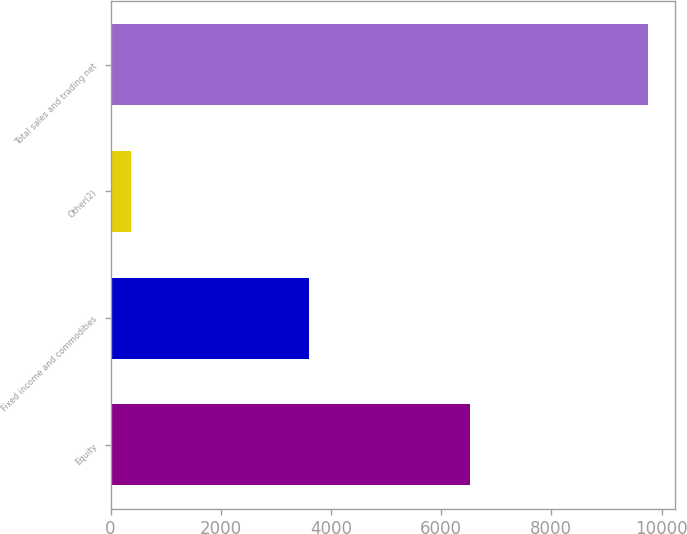Convert chart to OTSL. <chart><loc_0><loc_0><loc_500><loc_500><bar_chart><fcel>Equity<fcel>Fixed income and commodities<fcel>Other(2)<fcel>Total sales and trading net<nl><fcel>6529<fcel>3594<fcel>372<fcel>9751<nl></chart> 